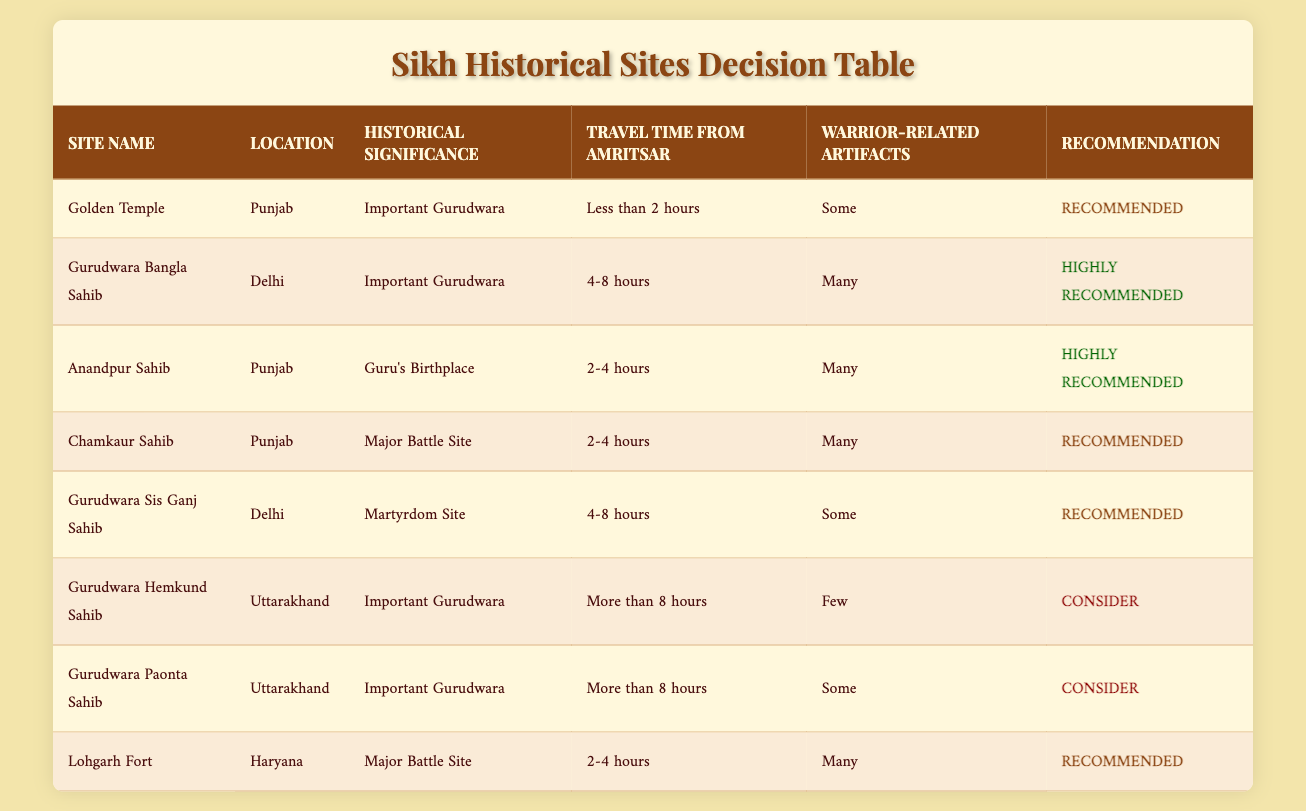What is the location of the Golden Temple? The Golden Temple is listed under the "Location" column in the table, and it shows "Punjab".
Answer: Punjab Which site is highly recommended and is a Guru's birthplace? Checking the table for "highly recommended" sites, Anandpur Sahib is identified under the "Historical Significance" column as the "Guru's Birthplace".
Answer: Anandpur Sahib How many sites are classified as "Recommended"? The "Recommendation" column shows that there are four sites marked as "Recommended": Golden Temple, Chamkaur Sahib, Gurudwara Sis Ganj Sahib, and Lohgarh Fort. Hence, there are four such sites.
Answer: Four Is there any site located in Haryana with warrior-related artifacts? Lohgarh Fort is located in Haryana and the "Warrior-related Artifacts" column indicates that it has "Many". Thus, the answer is affirmative as it fulfills both conditions.
Answer: Yes Which site has the longest travel time from Amritsar? The longest travel time mentioned in the table is "More than 8 hours", corresponding to Gurudwara Hemkund Sahib and Gurudwara Paonta Sahib. Thus, both have the longest travel time.
Answer: Gurudwara Hemkund Sahib and Gurudwara Paonta Sahib What is the average travel time of all recommended sites? The recommended sites are: Golden Temple (Less than 2 hours), Chamkaur Sahib (2-4 hours), Gurudwara Sis Ganj Sahib (4-8 hours), and Lohgarh Fort (2-4 hours). Converting "Less than 2 hours" to 1.5 hours, 2-4 hours to an average of 3 hours, 4-8 hours to an average of 6 hours, we calculate (1.5 + 3 + 6 + 3) / 4 = 3.375 hours on average.
Answer: 3.375 hours Are there any sites recommended that have "Few" warrior-related artifacts? Looking at the "Warrior-related Artifacts" column for recommended sites, Golden Temple has "Some", Gurudwara Sis Ganj Sahib has "Some", and Lohgarh Fort has "Many”. Thus, none among them has "Few" artifacts.
Answer: No Which important Gurudwara in Delhi is highly recommended? The table clearly indicates Gurudwara Bangla Sahib as an "Important Gurudwara" in Delhi with a recommendation status of "Highly Recommended".
Answer: Gurudwara Bangla Sahib How many sites in Punjab have "Many" warrior-related artifacts? The sites in Punjab are Anandpur Sahib, Chamkaur Sahib, and the Golden Temple. Anandpur Sahib and Chamkaur Sahib are noted as having "Many" warrior-related artifacts, totaling two such sites.
Answer: Two 